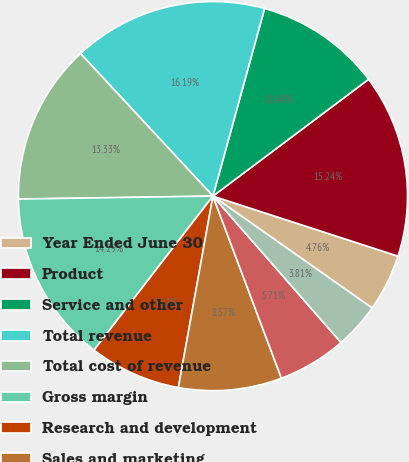<chart> <loc_0><loc_0><loc_500><loc_500><pie_chart><fcel>Year Ended June 30<fcel>Product<fcel>Service and other<fcel>Total revenue<fcel>Total cost of revenue<fcel>Gross margin<fcel>Research and development<fcel>Sales and marketing<fcel>General and administrative<fcel>Impairment and restructuring<nl><fcel>4.76%<fcel>15.24%<fcel>10.48%<fcel>16.19%<fcel>13.33%<fcel>14.29%<fcel>7.62%<fcel>8.57%<fcel>5.71%<fcel>3.81%<nl></chart> 